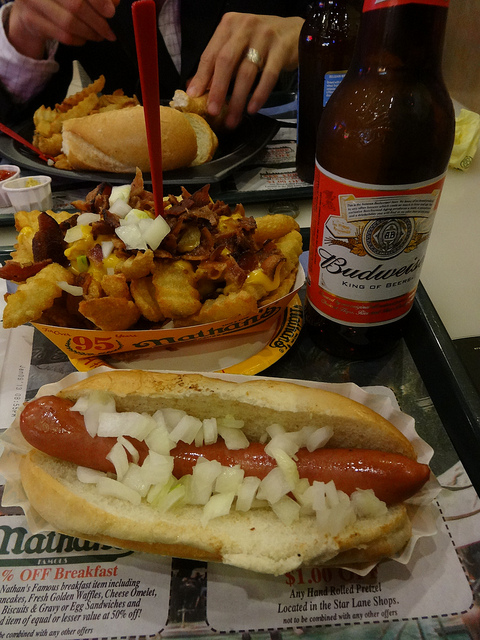Read and extract the text from this image. 95 Breakfast OFF Cheese Fresh Shops Lane Star the in Located Pretzel RoLled Hand $1.00 Condied off value lesses equal of and Sandwiches Egg Gravy Biscuits Waffles Golden Omelet, including breakfast Famous Nathan's KINO 